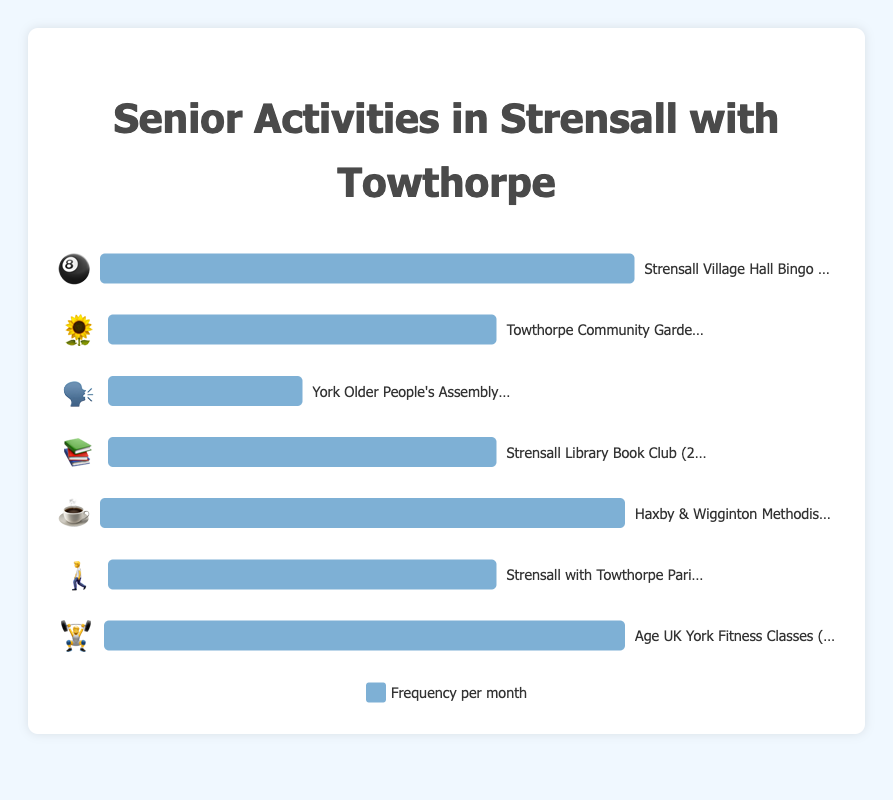What is the source of the data in this chart? The chart displays the frequency of social activities for seniors in Strensall with Towthorpe, each represented using emojis for a visual understanding.
Answer: Senior activities in Strensall with Towthorpe How many activities occur twice a month? First, identify the activities that have a frequency of 2/month: Towthorpe Community Garden Club (🌻), Strensall Library Book Club (📚), and Strensall with Towthorpe Parish Council Walks (🚶). Count these activities which are three.
Answer: 3 Which two activities have the highest frequency per month and how frequently do they occur? The activities with the highest bar width (100%) are Strensall Village Hall Bingo Night (🎱) and Haxby & Wigginton Methodist Church Coffee Morning (☕). Both occur 4 times a month.
Answer: Strensall Village Hall Bingo Night and Haxby & Wigginton Methodist Church Coffee Morning, 4 times each What is the combined frequency of the Towthorpe Community Garden Club (🌻) and Strensall Library Book Club (📚) per month? The Towthorpe Community Garden Club and Strensall Library Book Club each occur twice a month. Adding these frequencies together equals 4 times a month.
Answer: 4 times Which activity occurs the least frequently? Identify the shortest bar, which represents York Older People's Assembly Meetings (🗣️) occurring once a month.
Answer: York Older People's Assembly Meetings Compare the frequency of Strensall Village Hall Bingo Night (🎱) and Age UK York Fitness Classes (🏋️). Which one is more frequent and by how much? The frequency of Strensall Village Hall Bingo Night is 4 times a month, and Age UK York Fitness Classes is 3 times a month. Comparing them, the Bingo Night occurs 1 time more.
Answer: Strensall Village Hall Bingo Night, by 1 time What percentage of the maximum frequency is represented by Strensall with Towthorpe Parish Council Walks (🚶)? The maximum frequency is 4 times a month. The Parish Council Walks occur 2 times a month. Therefore, the percentage is (2/4) * 100 = 50%.
Answer: 50% 